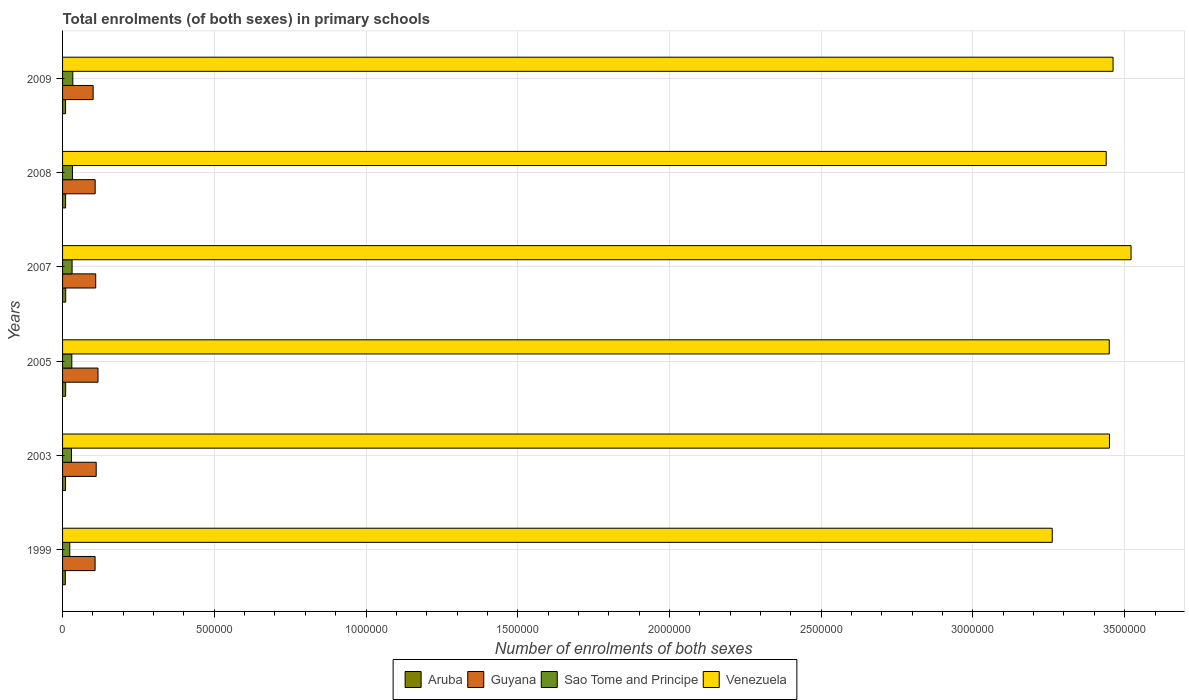How many different coloured bars are there?
Offer a very short reply. 4. How many groups of bars are there?
Offer a terse response. 6. Are the number of bars per tick equal to the number of legend labels?
Provide a succinct answer. Yes. Are the number of bars on each tick of the Y-axis equal?
Keep it short and to the point. Yes. How many bars are there on the 1st tick from the bottom?
Offer a very short reply. 4. What is the label of the 6th group of bars from the top?
Make the answer very short. 1999. What is the number of enrolments in primary schools in Venezuela in 2007?
Keep it short and to the point. 3.52e+06. Across all years, what is the maximum number of enrolments in primary schools in Guyana?
Provide a short and direct response. 1.17e+05. Across all years, what is the minimum number of enrolments in primary schools in Sao Tome and Principe?
Provide a short and direct response. 2.38e+04. In which year was the number of enrolments in primary schools in Guyana maximum?
Give a very brief answer. 2005. What is the total number of enrolments in primary schools in Venezuela in the graph?
Give a very brief answer. 2.06e+07. What is the difference between the number of enrolments in primary schools in Aruba in 2007 and that in 2009?
Offer a very short reply. 402. What is the difference between the number of enrolments in primary schools in Guyana in 2005 and the number of enrolments in primary schools in Aruba in 1999?
Provide a succinct answer. 1.08e+05. What is the average number of enrolments in primary schools in Venezuela per year?
Your answer should be very brief. 3.43e+06. In the year 2003, what is the difference between the number of enrolments in primary schools in Venezuela and number of enrolments in primary schools in Aruba?
Your answer should be very brief. 3.44e+06. In how many years, is the number of enrolments in primary schools in Venezuela greater than 1000000 ?
Provide a succinct answer. 6. What is the ratio of the number of enrolments in primary schools in Guyana in 2003 to that in 2008?
Make the answer very short. 1.03. Is the difference between the number of enrolments in primary schools in Venezuela in 1999 and 2009 greater than the difference between the number of enrolments in primary schools in Aruba in 1999 and 2009?
Your response must be concise. No. What is the difference between the highest and the second highest number of enrolments in primary schools in Guyana?
Offer a terse response. 5928. What is the difference between the highest and the lowest number of enrolments in primary schools in Aruba?
Your answer should be compact. 1250. Is the sum of the number of enrolments in primary schools in Sao Tome and Principe in 2003 and 2008 greater than the maximum number of enrolments in primary schools in Aruba across all years?
Make the answer very short. Yes. What does the 2nd bar from the top in 2003 represents?
Offer a very short reply. Sao Tome and Principe. What does the 1st bar from the bottom in 2005 represents?
Provide a short and direct response. Aruba. How many years are there in the graph?
Make the answer very short. 6. What is the difference between two consecutive major ticks on the X-axis?
Offer a terse response. 5.00e+05. Are the values on the major ticks of X-axis written in scientific E-notation?
Give a very brief answer. No. Does the graph contain any zero values?
Offer a very short reply. No. Where does the legend appear in the graph?
Your response must be concise. Bottom center. How are the legend labels stacked?
Provide a short and direct response. Horizontal. What is the title of the graph?
Provide a succinct answer. Total enrolments (of both sexes) in primary schools. Does "Singapore" appear as one of the legend labels in the graph?
Give a very brief answer. No. What is the label or title of the X-axis?
Your answer should be very brief. Number of enrolments of both sexes. What is the label or title of the Y-axis?
Your answer should be compact. Years. What is the Number of enrolments of both sexes in Aruba in 1999?
Provide a short and direct response. 9096. What is the Number of enrolments of both sexes of Guyana in 1999?
Keep it short and to the point. 1.07e+05. What is the Number of enrolments of both sexes of Sao Tome and Principe in 1999?
Offer a very short reply. 2.38e+04. What is the Number of enrolments of both sexes in Venezuela in 1999?
Provide a short and direct response. 3.26e+06. What is the Number of enrolments of both sexes of Aruba in 2003?
Provide a succinct answer. 9897. What is the Number of enrolments of both sexes in Guyana in 2003?
Your answer should be compact. 1.11e+05. What is the Number of enrolments of both sexes in Sao Tome and Principe in 2003?
Your response must be concise. 2.93e+04. What is the Number of enrolments of both sexes in Venezuela in 2003?
Give a very brief answer. 3.45e+06. What is the Number of enrolments of both sexes of Aruba in 2005?
Keep it short and to the point. 1.02e+04. What is the Number of enrolments of both sexes in Guyana in 2005?
Keep it short and to the point. 1.17e+05. What is the Number of enrolments of both sexes in Sao Tome and Principe in 2005?
Provide a short and direct response. 3.05e+04. What is the Number of enrolments of both sexes of Venezuela in 2005?
Your answer should be very brief. 3.45e+06. What is the Number of enrolments of both sexes of Aruba in 2007?
Your answer should be compact. 1.03e+04. What is the Number of enrolments of both sexes in Guyana in 2007?
Offer a very short reply. 1.09e+05. What is the Number of enrolments of both sexes of Sao Tome and Principe in 2007?
Give a very brief answer. 3.14e+04. What is the Number of enrolments of both sexes of Venezuela in 2007?
Keep it short and to the point. 3.52e+06. What is the Number of enrolments of both sexes of Aruba in 2008?
Your answer should be very brief. 1.00e+04. What is the Number of enrolments of both sexes in Guyana in 2008?
Your answer should be very brief. 1.07e+05. What is the Number of enrolments of both sexes of Sao Tome and Principe in 2008?
Your response must be concise. 3.26e+04. What is the Number of enrolments of both sexes of Venezuela in 2008?
Offer a terse response. 3.44e+06. What is the Number of enrolments of both sexes of Aruba in 2009?
Provide a short and direct response. 9944. What is the Number of enrolments of both sexes in Guyana in 2009?
Give a very brief answer. 1.01e+05. What is the Number of enrolments of both sexes of Sao Tome and Principe in 2009?
Your answer should be very brief. 3.38e+04. What is the Number of enrolments of both sexes in Venezuela in 2009?
Your response must be concise. 3.46e+06. Across all years, what is the maximum Number of enrolments of both sexes in Aruba?
Give a very brief answer. 1.03e+04. Across all years, what is the maximum Number of enrolments of both sexes of Guyana?
Your answer should be compact. 1.17e+05. Across all years, what is the maximum Number of enrolments of both sexes in Sao Tome and Principe?
Provide a succinct answer. 3.38e+04. Across all years, what is the maximum Number of enrolments of both sexes of Venezuela?
Keep it short and to the point. 3.52e+06. Across all years, what is the minimum Number of enrolments of both sexes of Aruba?
Your answer should be very brief. 9096. Across all years, what is the minimum Number of enrolments of both sexes of Guyana?
Keep it short and to the point. 1.01e+05. Across all years, what is the minimum Number of enrolments of both sexes in Sao Tome and Principe?
Make the answer very short. 2.38e+04. Across all years, what is the minimum Number of enrolments of both sexes in Venezuela?
Offer a terse response. 3.26e+06. What is the total Number of enrolments of both sexes in Aruba in the graph?
Keep it short and to the point. 5.95e+04. What is the total Number of enrolments of both sexes of Guyana in the graph?
Your answer should be compact. 6.52e+05. What is the total Number of enrolments of both sexes in Sao Tome and Principe in the graph?
Your answer should be very brief. 1.81e+05. What is the total Number of enrolments of both sexes of Venezuela in the graph?
Your answer should be compact. 2.06e+07. What is the difference between the Number of enrolments of both sexes in Aruba in 1999 and that in 2003?
Give a very brief answer. -801. What is the difference between the Number of enrolments of both sexes in Guyana in 1999 and that in 2003?
Keep it short and to the point. -3621. What is the difference between the Number of enrolments of both sexes in Sao Tome and Principe in 1999 and that in 2003?
Provide a succinct answer. -5578. What is the difference between the Number of enrolments of both sexes of Venezuela in 1999 and that in 2003?
Your answer should be very brief. -1.89e+05. What is the difference between the Number of enrolments of both sexes of Aruba in 1999 and that in 2005?
Your response must be concise. -1154. What is the difference between the Number of enrolments of both sexes of Guyana in 1999 and that in 2005?
Make the answer very short. -9549. What is the difference between the Number of enrolments of both sexes of Sao Tome and Principe in 1999 and that in 2005?
Make the answer very short. -6699. What is the difference between the Number of enrolments of both sexes in Venezuela in 1999 and that in 2005?
Make the answer very short. -1.88e+05. What is the difference between the Number of enrolments of both sexes in Aruba in 1999 and that in 2007?
Offer a very short reply. -1250. What is the difference between the Number of enrolments of both sexes in Guyana in 1999 and that in 2007?
Offer a very short reply. -2036. What is the difference between the Number of enrolments of both sexes of Sao Tome and Principe in 1999 and that in 2007?
Ensure brevity in your answer.  -7628. What is the difference between the Number of enrolments of both sexes in Venezuela in 1999 and that in 2007?
Provide a short and direct response. -2.60e+05. What is the difference between the Number of enrolments of both sexes in Aruba in 1999 and that in 2008?
Keep it short and to the point. -916. What is the difference between the Number of enrolments of both sexes in Guyana in 1999 and that in 2008?
Offer a terse response. -249. What is the difference between the Number of enrolments of both sexes in Sao Tome and Principe in 1999 and that in 2008?
Give a very brief answer. -8815. What is the difference between the Number of enrolments of both sexes in Venezuela in 1999 and that in 2008?
Ensure brevity in your answer.  -1.78e+05. What is the difference between the Number of enrolments of both sexes in Aruba in 1999 and that in 2009?
Ensure brevity in your answer.  -848. What is the difference between the Number of enrolments of both sexes in Guyana in 1999 and that in 2009?
Make the answer very short. 6447. What is the difference between the Number of enrolments of both sexes of Sao Tome and Principe in 1999 and that in 2009?
Your response must be concise. -1.00e+04. What is the difference between the Number of enrolments of both sexes of Venezuela in 1999 and that in 2009?
Provide a succinct answer. -2.00e+05. What is the difference between the Number of enrolments of both sexes in Aruba in 2003 and that in 2005?
Your response must be concise. -353. What is the difference between the Number of enrolments of both sexes of Guyana in 2003 and that in 2005?
Make the answer very short. -5928. What is the difference between the Number of enrolments of both sexes in Sao Tome and Principe in 2003 and that in 2005?
Ensure brevity in your answer.  -1121. What is the difference between the Number of enrolments of both sexes of Venezuela in 2003 and that in 2005?
Offer a terse response. 694. What is the difference between the Number of enrolments of both sexes in Aruba in 2003 and that in 2007?
Ensure brevity in your answer.  -449. What is the difference between the Number of enrolments of both sexes of Guyana in 2003 and that in 2007?
Offer a very short reply. 1585. What is the difference between the Number of enrolments of both sexes in Sao Tome and Principe in 2003 and that in 2007?
Give a very brief answer. -2050. What is the difference between the Number of enrolments of both sexes in Venezuela in 2003 and that in 2007?
Your response must be concise. -7.12e+04. What is the difference between the Number of enrolments of both sexes of Aruba in 2003 and that in 2008?
Keep it short and to the point. -115. What is the difference between the Number of enrolments of both sexes in Guyana in 2003 and that in 2008?
Ensure brevity in your answer.  3372. What is the difference between the Number of enrolments of both sexes in Sao Tome and Principe in 2003 and that in 2008?
Your answer should be very brief. -3237. What is the difference between the Number of enrolments of both sexes of Venezuela in 2003 and that in 2008?
Give a very brief answer. 1.08e+04. What is the difference between the Number of enrolments of both sexes in Aruba in 2003 and that in 2009?
Offer a very short reply. -47. What is the difference between the Number of enrolments of both sexes of Guyana in 2003 and that in 2009?
Provide a short and direct response. 1.01e+04. What is the difference between the Number of enrolments of both sexes of Sao Tome and Principe in 2003 and that in 2009?
Make the answer very short. -4442. What is the difference between the Number of enrolments of both sexes of Venezuela in 2003 and that in 2009?
Offer a very short reply. -1.18e+04. What is the difference between the Number of enrolments of both sexes of Aruba in 2005 and that in 2007?
Offer a very short reply. -96. What is the difference between the Number of enrolments of both sexes in Guyana in 2005 and that in 2007?
Provide a short and direct response. 7513. What is the difference between the Number of enrolments of both sexes in Sao Tome and Principe in 2005 and that in 2007?
Give a very brief answer. -929. What is the difference between the Number of enrolments of both sexes in Venezuela in 2005 and that in 2007?
Ensure brevity in your answer.  -7.18e+04. What is the difference between the Number of enrolments of both sexes of Aruba in 2005 and that in 2008?
Give a very brief answer. 238. What is the difference between the Number of enrolments of both sexes of Guyana in 2005 and that in 2008?
Keep it short and to the point. 9300. What is the difference between the Number of enrolments of both sexes in Sao Tome and Principe in 2005 and that in 2008?
Your answer should be very brief. -2116. What is the difference between the Number of enrolments of both sexes of Venezuela in 2005 and that in 2008?
Your response must be concise. 1.01e+04. What is the difference between the Number of enrolments of both sexes in Aruba in 2005 and that in 2009?
Your response must be concise. 306. What is the difference between the Number of enrolments of both sexes in Guyana in 2005 and that in 2009?
Offer a terse response. 1.60e+04. What is the difference between the Number of enrolments of both sexes in Sao Tome and Principe in 2005 and that in 2009?
Make the answer very short. -3321. What is the difference between the Number of enrolments of both sexes in Venezuela in 2005 and that in 2009?
Offer a terse response. -1.25e+04. What is the difference between the Number of enrolments of both sexes in Aruba in 2007 and that in 2008?
Keep it short and to the point. 334. What is the difference between the Number of enrolments of both sexes in Guyana in 2007 and that in 2008?
Provide a succinct answer. 1787. What is the difference between the Number of enrolments of both sexes of Sao Tome and Principe in 2007 and that in 2008?
Provide a short and direct response. -1187. What is the difference between the Number of enrolments of both sexes of Venezuela in 2007 and that in 2008?
Your answer should be compact. 8.19e+04. What is the difference between the Number of enrolments of both sexes of Aruba in 2007 and that in 2009?
Make the answer very short. 402. What is the difference between the Number of enrolments of both sexes of Guyana in 2007 and that in 2009?
Keep it short and to the point. 8483. What is the difference between the Number of enrolments of both sexes in Sao Tome and Principe in 2007 and that in 2009?
Make the answer very short. -2392. What is the difference between the Number of enrolments of both sexes of Venezuela in 2007 and that in 2009?
Your answer should be compact. 5.93e+04. What is the difference between the Number of enrolments of both sexes of Aruba in 2008 and that in 2009?
Make the answer very short. 68. What is the difference between the Number of enrolments of both sexes of Guyana in 2008 and that in 2009?
Offer a terse response. 6696. What is the difference between the Number of enrolments of both sexes in Sao Tome and Principe in 2008 and that in 2009?
Make the answer very short. -1205. What is the difference between the Number of enrolments of both sexes in Venezuela in 2008 and that in 2009?
Provide a short and direct response. -2.26e+04. What is the difference between the Number of enrolments of both sexes of Aruba in 1999 and the Number of enrolments of both sexes of Guyana in 2003?
Your answer should be compact. -1.02e+05. What is the difference between the Number of enrolments of both sexes in Aruba in 1999 and the Number of enrolments of both sexes in Sao Tome and Principe in 2003?
Offer a very short reply. -2.03e+04. What is the difference between the Number of enrolments of both sexes of Aruba in 1999 and the Number of enrolments of both sexes of Venezuela in 2003?
Offer a terse response. -3.44e+06. What is the difference between the Number of enrolments of both sexes of Guyana in 1999 and the Number of enrolments of both sexes of Sao Tome and Principe in 2003?
Provide a succinct answer. 7.79e+04. What is the difference between the Number of enrolments of both sexes in Guyana in 1999 and the Number of enrolments of both sexes in Venezuela in 2003?
Offer a terse response. -3.34e+06. What is the difference between the Number of enrolments of both sexes of Sao Tome and Principe in 1999 and the Number of enrolments of both sexes of Venezuela in 2003?
Offer a very short reply. -3.43e+06. What is the difference between the Number of enrolments of both sexes of Aruba in 1999 and the Number of enrolments of both sexes of Guyana in 2005?
Your response must be concise. -1.08e+05. What is the difference between the Number of enrolments of both sexes in Aruba in 1999 and the Number of enrolments of both sexes in Sao Tome and Principe in 2005?
Offer a very short reply. -2.14e+04. What is the difference between the Number of enrolments of both sexes of Aruba in 1999 and the Number of enrolments of both sexes of Venezuela in 2005?
Ensure brevity in your answer.  -3.44e+06. What is the difference between the Number of enrolments of both sexes in Guyana in 1999 and the Number of enrolments of both sexes in Sao Tome and Principe in 2005?
Your response must be concise. 7.67e+04. What is the difference between the Number of enrolments of both sexes of Guyana in 1999 and the Number of enrolments of both sexes of Venezuela in 2005?
Provide a short and direct response. -3.34e+06. What is the difference between the Number of enrolments of both sexes of Sao Tome and Principe in 1999 and the Number of enrolments of both sexes of Venezuela in 2005?
Your answer should be very brief. -3.43e+06. What is the difference between the Number of enrolments of both sexes of Aruba in 1999 and the Number of enrolments of both sexes of Guyana in 2007?
Keep it short and to the point. -1.00e+05. What is the difference between the Number of enrolments of both sexes of Aruba in 1999 and the Number of enrolments of both sexes of Sao Tome and Principe in 2007?
Give a very brief answer. -2.23e+04. What is the difference between the Number of enrolments of both sexes in Aruba in 1999 and the Number of enrolments of both sexes in Venezuela in 2007?
Give a very brief answer. -3.51e+06. What is the difference between the Number of enrolments of both sexes of Guyana in 1999 and the Number of enrolments of both sexes of Sao Tome and Principe in 2007?
Make the answer very short. 7.58e+04. What is the difference between the Number of enrolments of both sexes of Guyana in 1999 and the Number of enrolments of both sexes of Venezuela in 2007?
Offer a terse response. -3.41e+06. What is the difference between the Number of enrolments of both sexes in Sao Tome and Principe in 1999 and the Number of enrolments of both sexes in Venezuela in 2007?
Provide a short and direct response. -3.50e+06. What is the difference between the Number of enrolments of both sexes of Aruba in 1999 and the Number of enrolments of both sexes of Guyana in 2008?
Ensure brevity in your answer.  -9.84e+04. What is the difference between the Number of enrolments of both sexes in Aruba in 1999 and the Number of enrolments of both sexes in Sao Tome and Principe in 2008?
Give a very brief answer. -2.35e+04. What is the difference between the Number of enrolments of both sexes in Aruba in 1999 and the Number of enrolments of both sexes in Venezuela in 2008?
Offer a terse response. -3.43e+06. What is the difference between the Number of enrolments of both sexes in Guyana in 1999 and the Number of enrolments of both sexes in Sao Tome and Principe in 2008?
Your answer should be compact. 7.46e+04. What is the difference between the Number of enrolments of both sexes in Guyana in 1999 and the Number of enrolments of both sexes in Venezuela in 2008?
Offer a very short reply. -3.33e+06. What is the difference between the Number of enrolments of both sexes in Sao Tome and Principe in 1999 and the Number of enrolments of both sexes in Venezuela in 2008?
Provide a succinct answer. -3.42e+06. What is the difference between the Number of enrolments of both sexes of Aruba in 1999 and the Number of enrolments of both sexes of Guyana in 2009?
Make the answer very short. -9.17e+04. What is the difference between the Number of enrolments of both sexes of Aruba in 1999 and the Number of enrolments of both sexes of Sao Tome and Principe in 2009?
Offer a terse response. -2.47e+04. What is the difference between the Number of enrolments of both sexes of Aruba in 1999 and the Number of enrolments of both sexes of Venezuela in 2009?
Provide a succinct answer. -3.45e+06. What is the difference between the Number of enrolments of both sexes in Guyana in 1999 and the Number of enrolments of both sexes in Sao Tome and Principe in 2009?
Give a very brief answer. 7.34e+04. What is the difference between the Number of enrolments of both sexes in Guyana in 1999 and the Number of enrolments of both sexes in Venezuela in 2009?
Provide a succinct answer. -3.35e+06. What is the difference between the Number of enrolments of both sexes in Sao Tome and Principe in 1999 and the Number of enrolments of both sexes in Venezuela in 2009?
Provide a succinct answer. -3.44e+06. What is the difference between the Number of enrolments of both sexes of Aruba in 2003 and the Number of enrolments of both sexes of Guyana in 2005?
Give a very brief answer. -1.07e+05. What is the difference between the Number of enrolments of both sexes of Aruba in 2003 and the Number of enrolments of both sexes of Sao Tome and Principe in 2005?
Your answer should be compact. -2.06e+04. What is the difference between the Number of enrolments of both sexes in Aruba in 2003 and the Number of enrolments of both sexes in Venezuela in 2005?
Give a very brief answer. -3.44e+06. What is the difference between the Number of enrolments of both sexes in Guyana in 2003 and the Number of enrolments of both sexes in Sao Tome and Principe in 2005?
Provide a succinct answer. 8.04e+04. What is the difference between the Number of enrolments of both sexes in Guyana in 2003 and the Number of enrolments of both sexes in Venezuela in 2005?
Keep it short and to the point. -3.34e+06. What is the difference between the Number of enrolments of both sexes in Sao Tome and Principe in 2003 and the Number of enrolments of both sexes in Venezuela in 2005?
Ensure brevity in your answer.  -3.42e+06. What is the difference between the Number of enrolments of both sexes of Aruba in 2003 and the Number of enrolments of both sexes of Guyana in 2007?
Keep it short and to the point. -9.93e+04. What is the difference between the Number of enrolments of both sexes in Aruba in 2003 and the Number of enrolments of both sexes in Sao Tome and Principe in 2007?
Your response must be concise. -2.15e+04. What is the difference between the Number of enrolments of both sexes in Aruba in 2003 and the Number of enrolments of both sexes in Venezuela in 2007?
Keep it short and to the point. -3.51e+06. What is the difference between the Number of enrolments of both sexes in Guyana in 2003 and the Number of enrolments of both sexes in Sao Tome and Principe in 2007?
Give a very brief answer. 7.94e+04. What is the difference between the Number of enrolments of both sexes of Guyana in 2003 and the Number of enrolments of both sexes of Venezuela in 2007?
Provide a short and direct response. -3.41e+06. What is the difference between the Number of enrolments of both sexes in Sao Tome and Principe in 2003 and the Number of enrolments of both sexes in Venezuela in 2007?
Ensure brevity in your answer.  -3.49e+06. What is the difference between the Number of enrolments of both sexes of Aruba in 2003 and the Number of enrolments of both sexes of Guyana in 2008?
Provide a short and direct response. -9.76e+04. What is the difference between the Number of enrolments of both sexes of Aruba in 2003 and the Number of enrolments of both sexes of Sao Tome and Principe in 2008?
Offer a very short reply. -2.27e+04. What is the difference between the Number of enrolments of both sexes in Aruba in 2003 and the Number of enrolments of both sexes in Venezuela in 2008?
Offer a terse response. -3.43e+06. What is the difference between the Number of enrolments of both sexes of Guyana in 2003 and the Number of enrolments of both sexes of Sao Tome and Principe in 2008?
Provide a succinct answer. 7.82e+04. What is the difference between the Number of enrolments of both sexes of Guyana in 2003 and the Number of enrolments of both sexes of Venezuela in 2008?
Make the answer very short. -3.33e+06. What is the difference between the Number of enrolments of both sexes in Sao Tome and Principe in 2003 and the Number of enrolments of both sexes in Venezuela in 2008?
Offer a very short reply. -3.41e+06. What is the difference between the Number of enrolments of both sexes of Aruba in 2003 and the Number of enrolments of both sexes of Guyana in 2009?
Your answer should be very brief. -9.09e+04. What is the difference between the Number of enrolments of both sexes of Aruba in 2003 and the Number of enrolments of both sexes of Sao Tome and Principe in 2009?
Offer a very short reply. -2.39e+04. What is the difference between the Number of enrolments of both sexes of Aruba in 2003 and the Number of enrolments of both sexes of Venezuela in 2009?
Provide a short and direct response. -3.45e+06. What is the difference between the Number of enrolments of both sexes of Guyana in 2003 and the Number of enrolments of both sexes of Sao Tome and Principe in 2009?
Provide a succinct answer. 7.70e+04. What is the difference between the Number of enrolments of both sexes in Guyana in 2003 and the Number of enrolments of both sexes in Venezuela in 2009?
Offer a very short reply. -3.35e+06. What is the difference between the Number of enrolments of both sexes in Sao Tome and Principe in 2003 and the Number of enrolments of both sexes in Venezuela in 2009?
Give a very brief answer. -3.43e+06. What is the difference between the Number of enrolments of both sexes in Aruba in 2005 and the Number of enrolments of both sexes in Guyana in 2007?
Make the answer very short. -9.90e+04. What is the difference between the Number of enrolments of both sexes in Aruba in 2005 and the Number of enrolments of both sexes in Sao Tome and Principe in 2007?
Ensure brevity in your answer.  -2.11e+04. What is the difference between the Number of enrolments of both sexes of Aruba in 2005 and the Number of enrolments of both sexes of Venezuela in 2007?
Your answer should be very brief. -3.51e+06. What is the difference between the Number of enrolments of both sexes in Guyana in 2005 and the Number of enrolments of both sexes in Sao Tome and Principe in 2007?
Your answer should be compact. 8.54e+04. What is the difference between the Number of enrolments of both sexes of Guyana in 2005 and the Number of enrolments of both sexes of Venezuela in 2007?
Ensure brevity in your answer.  -3.40e+06. What is the difference between the Number of enrolments of both sexes of Sao Tome and Principe in 2005 and the Number of enrolments of both sexes of Venezuela in 2007?
Give a very brief answer. -3.49e+06. What is the difference between the Number of enrolments of both sexes of Aruba in 2005 and the Number of enrolments of both sexes of Guyana in 2008?
Keep it short and to the point. -9.72e+04. What is the difference between the Number of enrolments of both sexes of Aruba in 2005 and the Number of enrolments of both sexes of Sao Tome and Principe in 2008?
Your answer should be compact. -2.23e+04. What is the difference between the Number of enrolments of both sexes in Aruba in 2005 and the Number of enrolments of both sexes in Venezuela in 2008?
Your answer should be compact. -3.43e+06. What is the difference between the Number of enrolments of both sexes in Guyana in 2005 and the Number of enrolments of both sexes in Sao Tome and Principe in 2008?
Keep it short and to the point. 8.42e+04. What is the difference between the Number of enrolments of both sexes of Guyana in 2005 and the Number of enrolments of both sexes of Venezuela in 2008?
Provide a short and direct response. -3.32e+06. What is the difference between the Number of enrolments of both sexes of Sao Tome and Principe in 2005 and the Number of enrolments of both sexes of Venezuela in 2008?
Your response must be concise. -3.41e+06. What is the difference between the Number of enrolments of both sexes in Aruba in 2005 and the Number of enrolments of both sexes in Guyana in 2009?
Ensure brevity in your answer.  -9.05e+04. What is the difference between the Number of enrolments of both sexes of Aruba in 2005 and the Number of enrolments of both sexes of Sao Tome and Principe in 2009?
Provide a short and direct response. -2.35e+04. What is the difference between the Number of enrolments of both sexes in Aruba in 2005 and the Number of enrolments of both sexes in Venezuela in 2009?
Offer a very short reply. -3.45e+06. What is the difference between the Number of enrolments of both sexes in Guyana in 2005 and the Number of enrolments of both sexes in Sao Tome and Principe in 2009?
Provide a short and direct response. 8.30e+04. What is the difference between the Number of enrolments of both sexes of Guyana in 2005 and the Number of enrolments of both sexes of Venezuela in 2009?
Provide a short and direct response. -3.35e+06. What is the difference between the Number of enrolments of both sexes of Sao Tome and Principe in 2005 and the Number of enrolments of both sexes of Venezuela in 2009?
Provide a short and direct response. -3.43e+06. What is the difference between the Number of enrolments of both sexes of Aruba in 2007 and the Number of enrolments of both sexes of Guyana in 2008?
Give a very brief answer. -9.71e+04. What is the difference between the Number of enrolments of both sexes in Aruba in 2007 and the Number of enrolments of both sexes in Sao Tome and Principe in 2008?
Give a very brief answer. -2.22e+04. What is the difference between the Number of enrolments of both sexes of Aruba in 2007 and the Number of enrolments of both sexes of Venezuela in 2008?
Your answer should be very brief. -3.43e+06. What is the difference between the Number of enrolments of both sexes of Guyana in 2007 and the Number of enrolments of both sexes of Sao Tome and Principe in 2008?
Keep it short and to the point. 7.67e+04. What is the difference between the Number of enrolments of both sexes in Guyana in 2007 and the Number of enrolments of both sexes in Venezuela in 2008?
Provide a succinct answer. -3.33e+06. What is the difference between the Number of enrolments of both sexes in Sao Tome and Principe in 2007 and the Number of enrolments of both sexes in Venezuela in 2008?
Offer a terse response. -3.41e+06. What is the difference between the Number of enrolments of both sexes in Aruba in 2007 and the Number of enrolments of both sexes in Guyana in 2009?
Ensure brevity in your answer.  -9.04e+04. What is the difference between the Number of enrolments of both sexes of Aruba in 2007 and the Number of enrolments of both sexes of Sao Tome and Principe in 2009?
Your answer should be very brief. -2.34e+04. What is the difference between the Number of enrolments of both sexes in Aruba in 2007 and the Number of enrolments of both sexes in Venezuela in 2009?
Provide a short and direct response. -3.45e+06. What is the difference between the Number of enrolments of both sexes in Guyana in 2007 and the Number of enrolments of both sexes in Sao Tome and Principe in 2009?
Provide a short and direct response. 7.55e+04. What is the difference between the Number of enrolments of both sexes of Guyana in 2007 and the Number of enrolments of both sexes of Venezuela in 2009?
Provide a succinct answer. -3.35e+06. What is the difference between the Number of enrolments of both sexes of Sao Tome and Principe in 2007 and the Number of enrolments of both sexes of Venezuela in 2009?
Offer a terse response. -3.43e+06. What is the difference between the Number of enrolments of both sexes of Aruba in 2008 and the Number of enrolments of both sexes of Guyana in 2009?
Your answer should be very brief. -9.07e+04. What is the difference between the Number of enrolments of both sexes of Aruba in 2008 and the Number of enrolments of both sexes of Sao Tome and Principe in 2009?
Make the answer very short. -2.38e+04. What is the difference between the Number of enrolments of both sexes of Aruba in 2008 and the Number of enrolments of both sexes of Venezuela in 2009?
Ensure brevity in your answer.  -3.45e+06. What is the difference between the Number of enrolments of both sexes of Guyana in 2008 and the Number of enrolments of both sexes of Sao Tome and Principe in 2009?
Give a very brief answer. 7.37e+04. What is the difference between the Number of enrolments of both sexes of Guyana in 2008 and the Number of enrolments of both sexes of Venezuela in 2009?
Your response must be concise. -3.35e+06. What is the difference between the Number of enrolments of both sexes in Sao Tome and Principe in 2008 and the Number of enrolments of both sexes in Venezuela in 2009?
Your answer should be compact. -3.43e+06. What is the average Number of enrolments of both sexes of Aruba per year?
Provide a short and direct response. 9924.17. What is the average Number of enrolments of both sexes in Guyana per year?
Your answer should be very brief. 1.09e+05. What is the average Number of enrolments of both sexes in Sao Tome and Principe per year?
Ensure brevity in your answer.  3.02e+04. What is the average Number of enrolments of both sexes of Venezuela per year?
Your response must be concise. 3.43e+06. In the year 1999, what is the difference between the Number of enrolments of both sexes of Aruba and Number of enrolments of both sexes of Guyana?
Provide a succinct answer. -9.81e+04. In the year 1999, what is the difference between the Number of enrolments of both sexes in Aruba and Number of enrolments of both sexes in Sao Tome and Principe?
Give a very brief answer. -1.47e+04. In the year 1999, what is the difference between the Number of enrolments of both sexes in Aruba and Number of enrolments of both sexes in Venezuela?
Ensure brevity in your answer.  -3.25e+06. In the year 1999, what is the difference between the Number of enrolments of both sexes in Guyana and Number of enrolments of both sexes in Sao Tome and Principe?
Ensure brevity in your answer.  8.34e+04. In the year 1999, what is the difference between the Number of enrolments of both sexes of Guyana and Number of enrolments of both sexes of Venezuela?
Offer a very short reply. -3.15e+06. In the year 1999, what is the difference between the Number of enrolments of both sexes in Sao Tome and Principe and Number of enrolments of both sexes in Venezuela?
Your answer should be very brief. -3.24e+06. In the year 2003, what is the difference between the Number of enrolments of both sexes of Aruba and Number of enrolments of both sexes of Guyana?
Give a very brief answer. -1.01e+05. In the year 2003, what is the difference between the Number of enrolments of both sexes of Aruba and Number of enrolments of both sexes of Sao Tome and Principe?
Provide a succinct answer. -1.94e+04. In the year 2003, what is the difference between the Number of enrolments of both sexes of Aruba and Number of enrolments of both sexes of Venezuela?
Your response must be concise. -3.44e+06. In the year 2003, what is the difference between the Number of enrolments of both sexes in Guyana and Number of enrolments of both sexes in Sao Tome and Principe?
Your response must be concise. 8.15e+04. In the year 2003, what is the difference between the Number of enrolments of both sexes of Guyana and Number of enrolments of both sexes of Venezuela?
Your answer should be compact. -3.34e+06. In the year 2003, what is the difference between the Number of enrolments of both sexes of Sao Tome and Principe and Number of enrolments of both sexes of Venezuela?
Offer a very short reply. -3.42e+06. In the year 2005, what is the difference between the Number of enrolments of both sexes of Aruba and Number of enrolments of both sexes of Guyana?
Offer a terse response. -1.07e+05. In the year 2005, what is the difference between the Number of enrolments of both sexes of Aruba and Number of enrolments of both sexes of Sao Tome and Principe?
Provide a succinct answer. -2.02e+04. In the year 2005, what is the difference between the Number of enrolments of both sexes in Aruba and Number of enrolments of both sexes in Venezuela?
Keep it short and to the point. -3.44e+06. In the year 2005, what is the difference between the Number of enrolments of both sexes in Guyana and Number of enrolments of both sexes in Sao Tome and Principe?
Ensure brevity in your answer.  8.63e+04. In the year 2005, what is the difference between the Number of enrolments of both sexes of Guyana and Number of enrolments of both sexes of Venezuela?
Ensure brevity in your answer.  -3.33e+06. In the year 2005, what is the difference between the Number of enrolments of both sexes in Sao Tome and Principe and Number of enrolments of both sexes in Venezuela?
Ensure brevity in your answer.  -3.42e+06. In the year 2007, what is the difference between the Number of enrolments of both sexes in Aruba and Number of enrolments of both sexes in Guyana?
Ensure brevity in your answer.  -9.89e+04. In the year 2007, what is the difference between the Number of enrolments of both sexes in Aruba and Number of enrolments of both sexes in Sao Tome and Principe?
Offer a very short reply. -2.11e+04. In the year 2007, what is the difference between the Number of enrolments of both sexes in Aruba and Number of enrolments of both sexes in Venezuela?
Provide a short and direct response. -3.51e+06. In the year 2007, what is the difference between the Number of enrolments of both sexes in Guyana and Number of enrolments of both sexes in Sao Tome and Principe?
Offer a terse response. 7.78e+04. In the year 2007, what is the difference between the Number of enrolments of both sexes of Guyana and Number of enrolments of both sexes of Venezuela?
Your answer should be compact. -3.41e+06. In the year 2007, what is the difference between the Number of enrolments of both sexes of Sao Tome and Principe and Number of enrolments of both sexes of Venezuela?
Give a very brief answer. -3.49e+06. In the year 2008, what is the difference between the Number of enrolments of both sexes of Aruba and Number of enrolments of both sexes of Guyana?
Make the answer very short. -9.74e+04. In the year 2008, what is the difference between the Number of enrolments of both sexes in Aruba and Number of enrolments of both sexes in Sao Tome and Principe?
Offer a terse response. -2.26e+04. In the year 2008, what is the difference between the Number of enrolments of both sexes of Aruba and Number of enrolments of both sexes of Venezuela?
Give a very brief answer. -3.43e+06. In the year 2008, what is the difference between the Number of enrolments of both sexes in Guyana and Number of enrolments of both sexes in Sao Tome and Principe?
Provide a short and direct response. 7.49e+04. In the year 2008, what is the difference between the Number of enrolments of both sexes of Guyana and Number of enrolments of both sexes of Venezuela?
Make the answer very short. -3.33e+06. In the year 2008, what is the difference between the Number of enrolments of both sexes in Sao Tome and Principe and Number of enrolments of both sexes in Venezuela?
Offer a very short reply. -3.41e+06. In the year 2009, what is the difference between the Number of enrolments of both sexes of Aruba and Number of enrolments of both sexes of Guyana?
Your answer should be compact. -9.08e+04. In the year 2009, what is the difference between the Number of enrolments of both sexes in Aruba and Number of enrolments of both sexes in Sao Tome and Principe?
Your response must be concise. -2.38e+04. In the year 2009, what is the difference between the Number of enrolments of both sexes of Aruba and Number of enrolments of both sexes of Venezuela?
Your answer should be compact. -3.45e+06. In the year 2009, what is the difference between the Number of enrolments of both sexes of Guyana and Number of enrolments of both sexes of Sao Tome and Principe?
Keep it short and to the point. 6.70e+04. In the year 2009, what is the difference between the Number of enrolments of both sexes in Guyana and Number of enrolments of both sexes in Venezuela?
Ensure brevity in your answer.  -3.36e+06. In the year 2009, what is the difference between the Number of enrolments of both sexes in Sao Tome and Principe and Number of enrolments of both sexes in Venezuela?
Provide a short and direct response. -3.43e+06. What is the ratio of the Number of enrolments of both sexes of Aruba in 1999 to that in 2003?
Make the answer very short. 0.92. What is the ratio of the Number of enrolments of both sexes of Guyana in 1999 to that in 2003?
Your answer should be very brief. 0.97. What is the ratio of the Number of enrolments of both sexes in Sao Tome and Principe in 1999 to that in 2003?
Give a very brief answer. 0.81. What is the ratio of the Number of enrolments of both sexes of Venezuela in 1999 to that in 2003?
Your answer should be compact. 0.95. What is the ratio of the Number of enrolments of both sexes in Aruba in 1999 to that in 2005?
Give a very brief answer. 0.89. What is the ratio of the Number of enrolments of both sexes of Guyana in 1999 to that in 2005?
Ensure brevity in your answer.  0.92. What is the ratio of the Number of enrolments of both sexes in Sao Tome and Principe in 1999 to that in 2005?
Your response must be concise. 0.78. What is the ratio of the Number of enrolments of both sexes of Venezuela in 1999 to that in 2005?
Make the answer very short. 0.95. What is the ratio of the Number of enrolments of both sexes of Aruba in 1999 to that in 2007?
Your answer should be compact. 0.88. What is the ratio of the Number of enrolments of both sexes of Guyana in 1999 to that in 2007?
Make the answer very short. 0.98. What is the ratio of the Number of enrolments of both sexes in Sao Tome and Principe in 1999 to that in 2007?
Your response must be concise. 0.76. What is the ratio of the Number of enrolments of both sexes in Venezuela in 1999 to that in 2007?
Provide a short and direct response. 0.93. What is the ratio of the Number of enrolments of both sexes in Aruba in 1999 to that in 2008?
Provide a succinct answer. 0.91. What is the ratio of the Number of enrolments of both sexes in Sao Tome and Principe in 1999 to that in 2008?
Offer a terse response. 0.73. What is the ratio of the Number of enrolments of both sexes of Venezuela in 1999 to that in 2008?
Give a very brief answer. 0.95. What is the ratio of the Number of enrolments of both sexes in Aruba in 1999 to that in 2009?
Give a very brief answer. 0.91. What is the ratio of the Number of enrolments of both sexes of Guyana in 1999 to that in 2009?
Offer a very short reply. 1.06. What is the ratio of the Number of enrolments of both sexes in Sao Tome and Principe in 1999 to that in 2009?
Ensure brevity in your answer.  0.7. What is the ratio of the Number of enrolments of both sexes of Venezuela in 1999 to that in 2009?
Ensure brevity in your answer.  0.94. What is the ratio of the Number of enrolments of both sexes in Aruba in 2003 to that in 2005?
Keep it short and to the point. 0.97. What is the ratio of the Number of enrolments of both sexes in Guyana in 2003 to that in 2005?
Your answer should be very brief. 0.95. What is the ratio of the Number of enrolments of both sexes of Sao Tome and Principe in 2003 to that in 2005?
Offer a very short reply. 0.96. What is the ratio of the Number of enrolments of both sexes of Aruba in 2003 to that in 2007?
Provide a short and direct response. 0.96. What is the ratio of the Number of enrolments of both sexes of Guyana in 2003 to that in 2007?
Your answer should be very brief. 1.01. What is the ratio of the Number of enrolments of both sexes of Sao Tome and Principe in 2003 to that in 2007?
Give a very brief answer. 0.93. What is the ratio of the Number of enrolments of both sexes in Venezuela in 2003 to that in 2007?
Ensure brevity in your answer.  0.98. What is the ratio of the Number of enrolments of both sexes of Aruba in 2003 to that in 2008?
Offer a very short reply. 0.99. What is the ratio of the Number of enrolments of both sexes of Guyana in 2003 to that in 2008?
Ensure brevity in your answer.  1.03. What is the ratio of the Number of enrolments of both sexes in Sao Tome and Principe in 2003 to that in 2008?
Provide a short and direct response. 0.9. What is the ratio of the Number of enrolments of both sexes in Aruba in 2003 to that in 2009?
Offer a terse response. 1. What is the ratio of the Number of enrolments of both sexes of Guyana in 2003 to that in 2009?
Provide a succinct answer. 1.1. What is the ratio of the Number of enrolments of both sexes in Sao Tome and Principe in 2003 to that in 2009?
Ensure brevity in your answer.  0.87. What is the ratio of the Number of enrolments of both sexes of Venezuela in 2003 to that in 2009?
Give a very brief answer. 1. What is the ratio of the Number of enrolments of both sexes of Aruba in 2005 to that in 2007?
Your answer should be compact. 0.99. What is the ratio of the Number of enrolments of both sexes of Guyana in 2005 to that in 2007?
Your response must be concise. 1.07. What is the ratio of the Number of enrolments of both sexes in Sao Tome and Principe in 2005 to that in 2007?
Your answer should be compact. 0.97. What is the ratio of the Number of enrolments of both sexes of Venezuela in 2005 to that in 2007?
Keep it short and to the point. 0.98. What is the ratio of the Number of enrolments of both sexes of Aruba in 2005 to that in 2008?
Keep it short and to the point. 1.02. What is the ratio of the Number of enrolments of both sexes in Guyana in 2005 to that in 2008?
Your answer should be very brief. 1.09. What is the ratio of the Number of enrolments of both sexes in Sao Tome and Principe in 2005 to that in 2008?
Your response must be concise. 0.94. What is the ratio of the Number of enrolments of both sexes in Venezuela in 2005 to that in 2008?
Your response must be concise. 1. What is the ratio of the Number of enrolments of both sexes of Aruba in 2005 to that in 2009?
Offer a very short reply. 1.03. What is the ratio of the Number of enrolments of both sexes of Guyana in 2005 to that in 2009?
Ensure brevity in your answer.  1.16. What is the ratio of the Number of enrolments of both sexes of Sao Tome and Principe in 2005 to that in 2009?
Give a very brief answer. 0.9. What is the ratio of the Number of enrolments of both sexes of Aruba in 2007 to that in 2008?
Offer a very short reply. 1.03. What is the ratio of the Number of enrolments of both sexes in Guyana in 2007 to that in 2008?
Offer a very short reply. 1.02. What is the ratio of the Number of enrolments of both sexes in Sao Tome and Principe in 2007 to that in 2008?
Your response must be concise. 0.96. What is the ratio of the Number of enrolments of both sexes in Venezuela in 2007 to that in 2008?
Ensure brevity in your answer.  1.02. What is the ratio of the Number of enrolments of both sexes in Aruba in 2007 to that in 2009?
Offer a very short reply. 1.04. What is the ratio of the Number of enrolments of both sexes of Guyana in 2007 to that in 2009?
Your response must be concise. 1.08. What is the ratio of the Number of enrolments of both sexes of Sao Tome and Principe in 2007 to that in 2009?
Keep it short and to the point. 0.93. What is the ratio of the Number of enrolments of both sexes of Venezuela in 2007 to that in 2009?
Provide a short and direct response. 1.02. What is the ratio of the Number of enrolments of both sexes of Aruba in 2008 to that in 2009?
Ensure brevity in your answer.  1.01. What is the ratio of the Number of enrolments of both sexes in Guyana in 2008 to that in 2009?
Ensure brevity in your answer.  1.07. What is the ratio of the Number of enrolments of both sexes of Sao Tome and Principe in 2008 to that in 2009?
Offer a very short reply. 0.96. What is the ratio of the Number of enrolments of both sexes of Venezuela in 2008 to that in 2009?
Make the answer very short. 0.99. What is the difference between the highest and the second highest Number of enrolments of both sexes in Aruba?
Make the answer very short. 96. What is the difference between the highest and the second highest Number of enrolments of both sexes of Guyana?
Give a very brief answer. 5928. What is the difference between the highest and the second highest Number of enrolments of both sexes in Sao Tome and Principe?
Provide a succinct answer. 1205. What is the difference between the highest and the second highest Number of enrolments of both sexes in Venezuela?
Make the answer very short. 5.93e+04. What is the difference between the highest and the lowest Number of enrolments of both sexes in Aruba?
Your response must be concise. 1250. What is the difference between the highest and the lowest Number of enrolments of both sexes of Guyana?
Ensure brevity in your answer.  1.60e+04. What is the difference between the highest and the lowest Number of enrolments of both sexes of Sao Tome and Principe?
Give a very brief answer. 1.00e+04. What is the difference between the highest and the lowest Number of enrolments of both sexes in Venezuela?
Your answer should be very brief. 2.60e+05. 